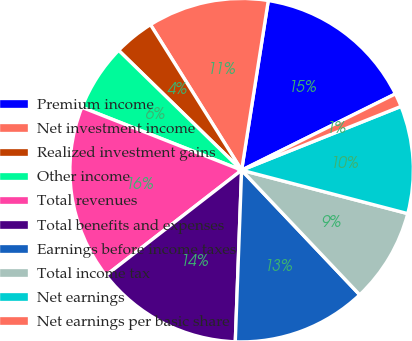<chart> <loc_0><loc_0><loc_500><loc_500><pie_chart><fcel>Premium income<fcel>Net investment income<fcel>Realized investment gains<fcel>Other income<fcel>Total revenues<fcel>Total benefits and expenses<fcel>Earnings before income taxes<fcel>Total income tax<fcel>Net earnings<fcel>Net earnings per basic share<nl><fcel>15.19%<fcel>11.39%<fcel>3.8%<fcel>6.33%<fcel>16.46%<fcel>13.92%<fcel>12.66%<fcel>8.86%<fcel>10.13%<fcel>1.27%<nl></chart> 